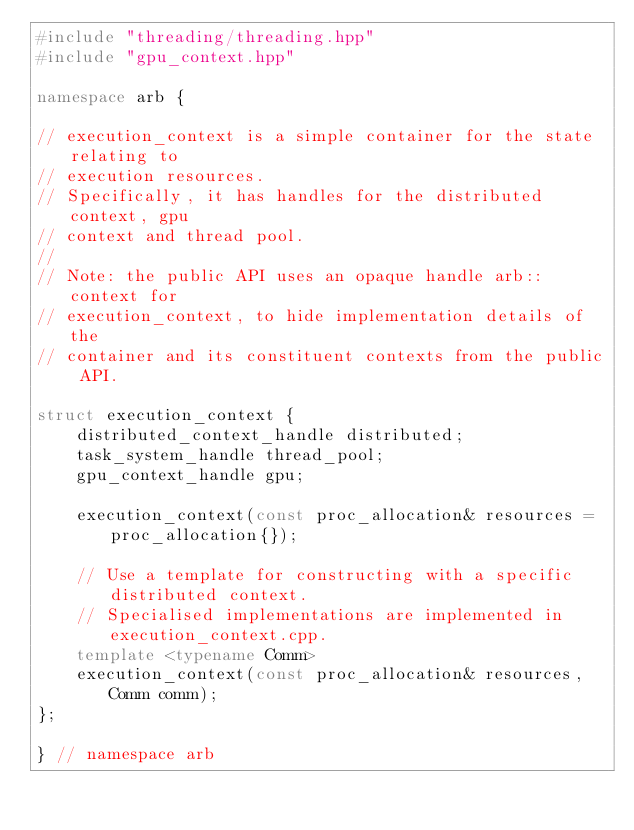Convert code to text. <code><loc_0><loc_0><loc_500><loc_500><_C++_>#include "threading/threading.hpp"
#include "gpu_context.hpp"

namespace arb {

// execution_context is a simple container for the state relating to
// execution resources.
// Specifically, it has handles for the distributed context, gpu
// context and thread pool.
//
// Note: the public API uses an opaque handle arb::context for
// execution_context, to hide implementation details of the
// container and its constituent contexts from the public API.

struct execution_context {
    distributed_context_handle distributed;
    task_system_handle thread_pool;
    gpu_context_handle gpu;

    execution_context(const proc_allocation& resources = proc_allocation{});

    // Use a template for constructing with a specific distributed context.
    // Specialised implementations are implemented in execution_context.cpp.
    template <typename Comm>
    execution_context(const proc_allocation& resources, Comm comm);
};

} // namespace arb
</code> 